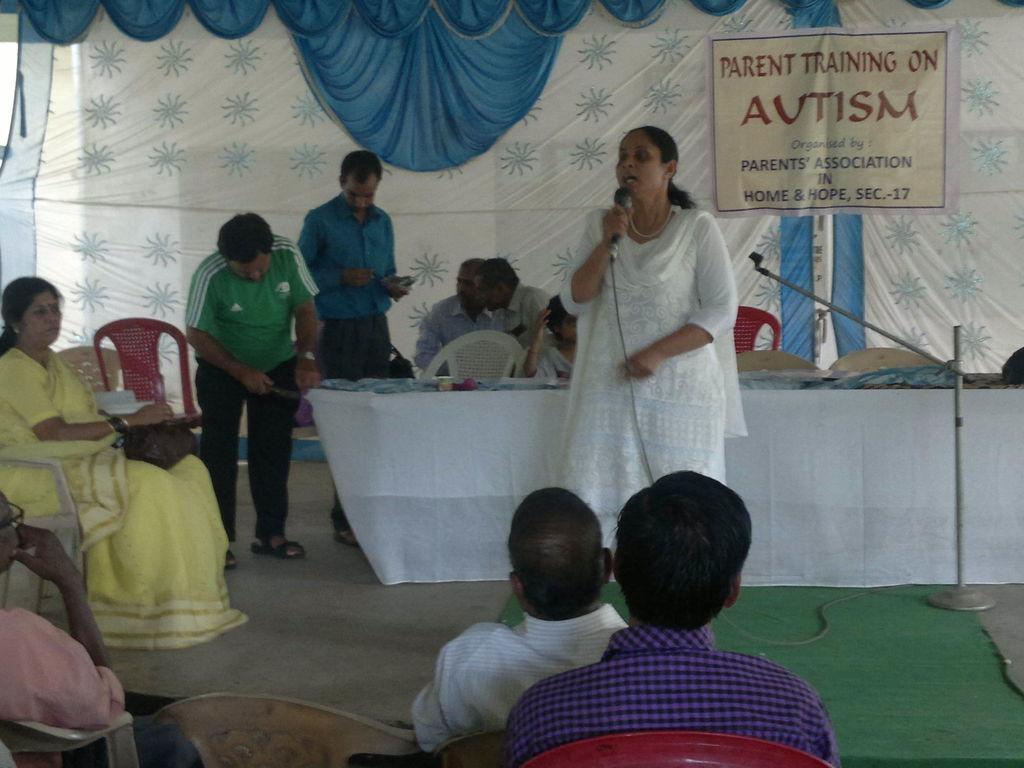Describe this image in one or two sentences. As we can see in the image there are few people here and there, chairs, banner, cloth and a table. On table there is a white color cloth and here there is a mic. 